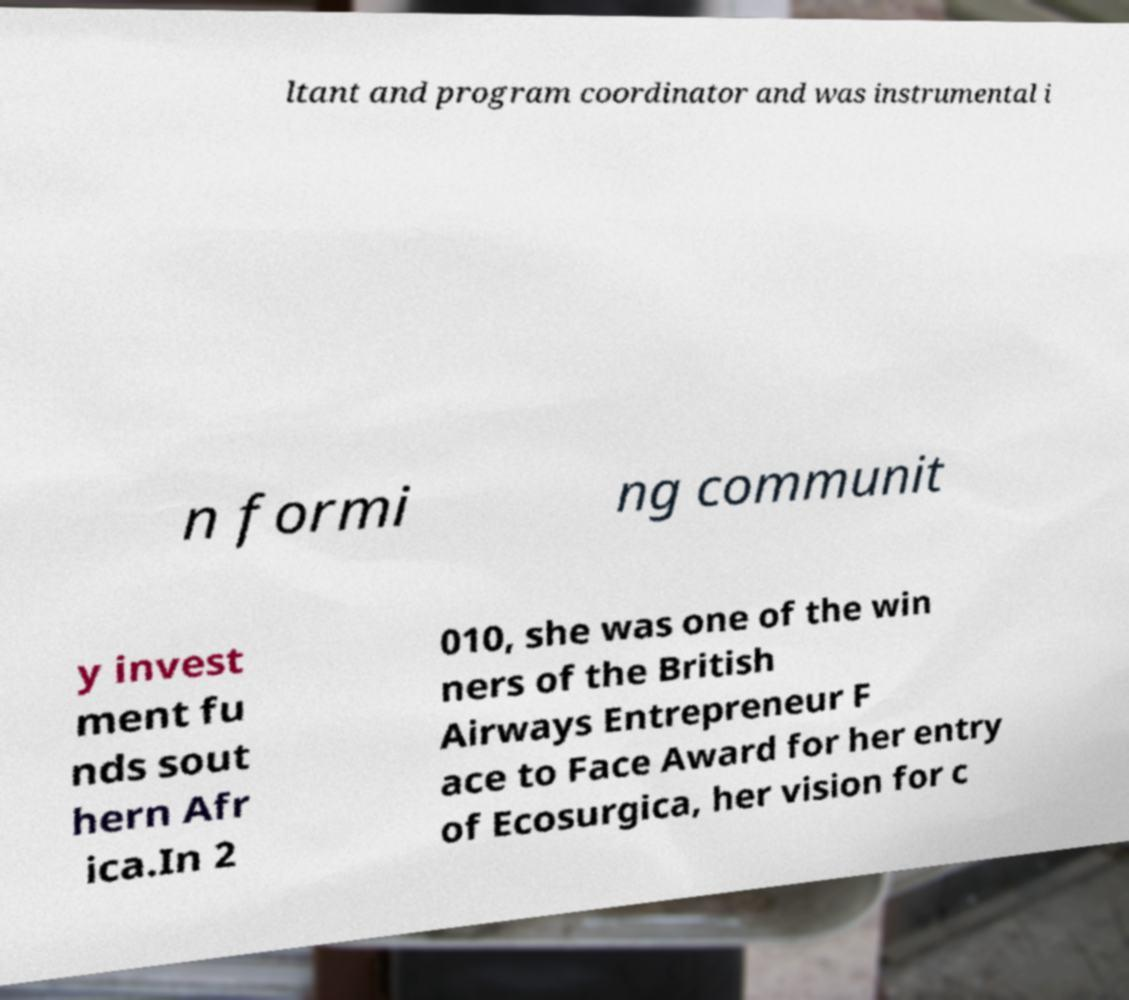There's text embedded in this image that I need extracted. Can you transcribe it verbatim? ltant and program coordinator and was instrumental i n formi ng communit y invest ment fu nds sout hern Afr ica.In 2 010, she was one of the win ners of the British Airways Entrepreneur F ace to Face Award for her entry of Ecosurgica, her vision for c 